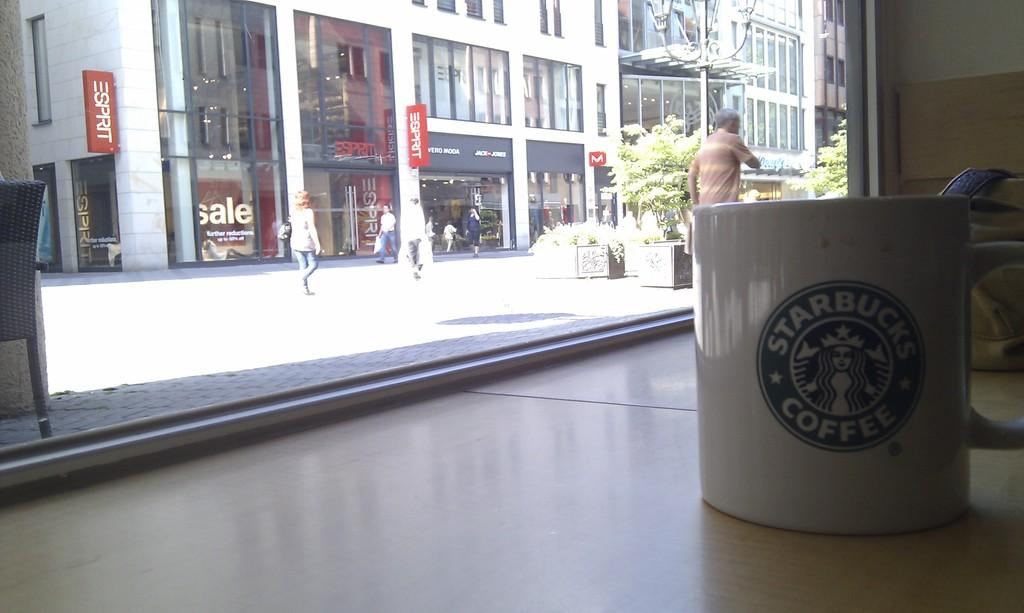<image>
Create a compact narrative representing the image presented. A Starbucks Coffee mug sits near the window where people can be seen walking by buildings. 